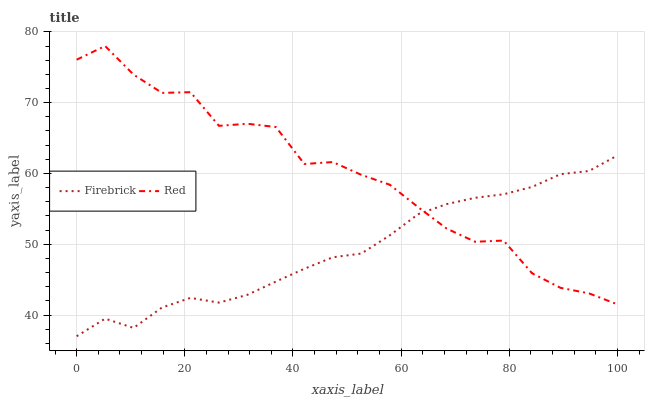Does Red have the minimum area under the curve?
Answer yes or no. No. Is Red the smoothest?
Answer yes or no. No. Does Red have the lowest value?
Answer yes or no. No. 